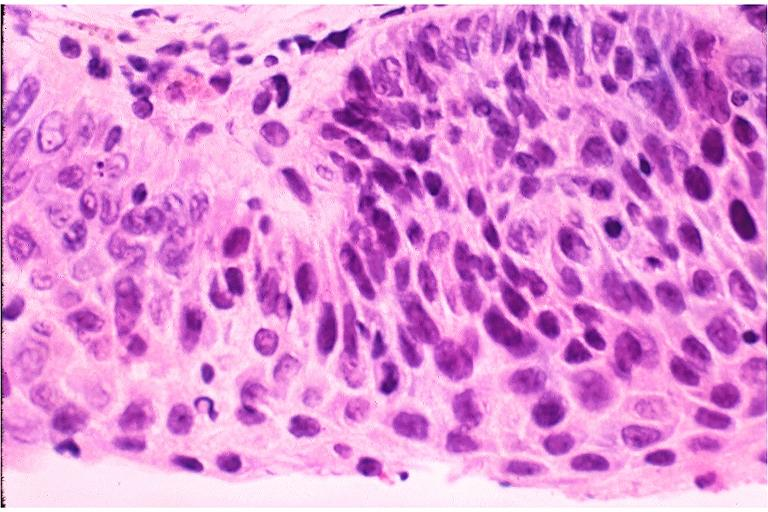s focal hemorrhagic infarction well shown present?
Answer the question using a single word or phrase. No 